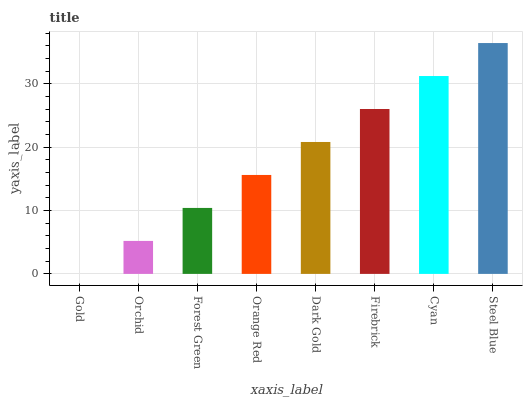Is Gold the minimum?
Answer yes or no. Yes. Is Steel Blue the maximum?
Answer yes or no. Yes. Is Orchid the minimum?
Answer yes or no. No. Is Orchid the maximum?
Answer yes or no. No. Is Orchid greater than Gold?
Answer yes or no. Yes. Is Gold less than Orchid?
Answer yes or no. Yes. Is Gold greater than Orchid?
Answer yes or no. No. Is Orchid less than Gold?
Answer yes or no. No. Is Dark Gold the high median?
Answer yes or no. Yes. Is Orange Red the low median?
Answer yes or no. Yes. Is Steel Blue the high median?
Answer yes or no. No. Is Gold the low median?
Answer yes or no. No. 